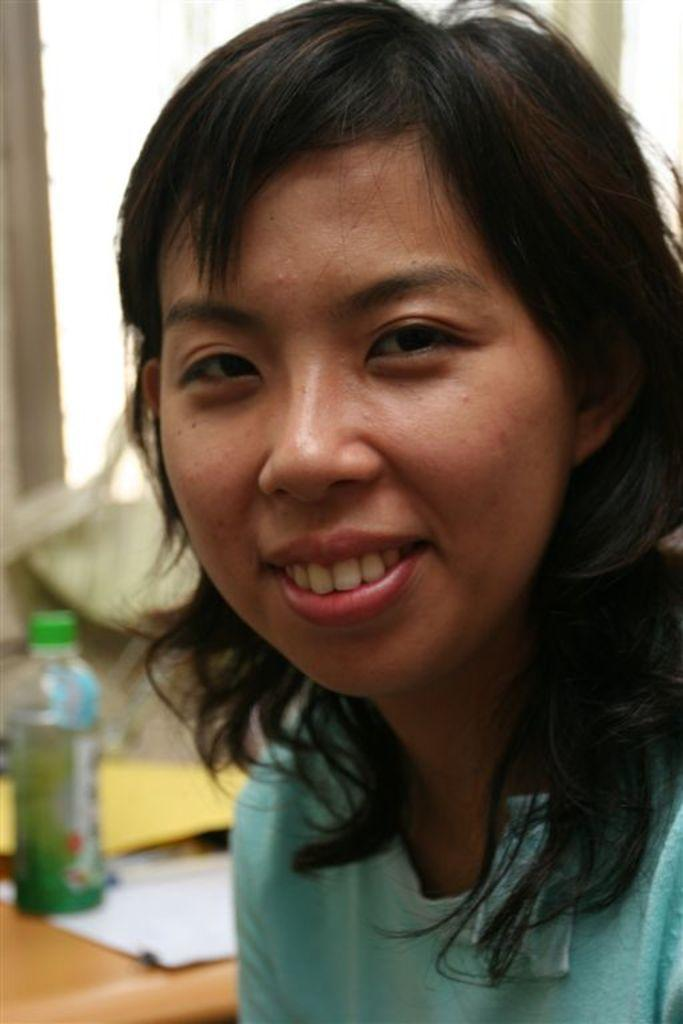Who is present in the image? There are women in the image. What are the women wearing? The women are wearing T-shirts. What is the facial expression of the women? The women are smiling. What can be seen in the background of the image? There is a bottle, a paper on a table, and a window in the background of the image. How many rings are the women wearing in the image? There is no mention of rings in the image, so we cannot determine how many rings the women are wearing. Are there any sheep visible in the image? No, there are no sheep present in the image. 